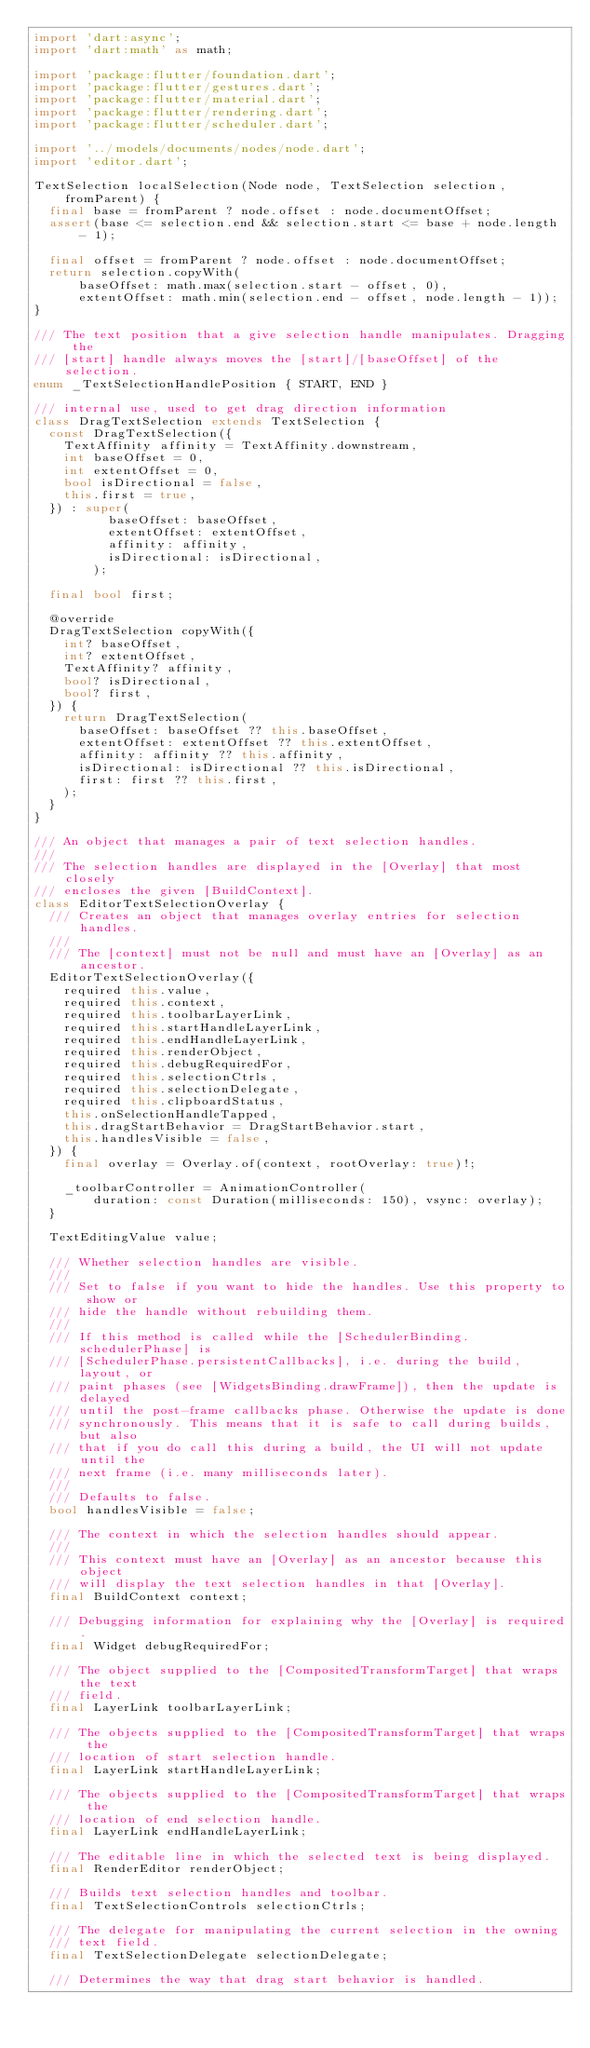<code> <loc_0><loc_0><loc_500><loc_500><_Dart_>import 'dart:async';
import 'dart:math' as math;

import 'package:flutter/foundation.dart';
import 'package:flutter/gestures.dart';
import 'package:flutter/material.dart';
import 'package:flutter/rendering.dart';
import 'package:flutter/scheduler.dart';

import '../models/documents/nodes/node.dart';
import 'editor.dart';

TextSelection localSelection(Node node, TextSelection selection, fromParent) {
  final base = fromParent ? node.offset : node.documentOffset;
  assert(base <= selection.end && selection.start <= base + node.length - 1);

  final offset = fromParent ? node.offset : node.documentOffset;
  return selection.copyWith(
      baseOffset: math.max(selection.start - offset, 0),
      extentOffset: math.min(selection.end - offset, node.length - 1));
}

/// The text position that a give selection handle manipulates. Dragging the
/// [start] handle always moves the [start]/[baseOffset] of the selection.
enum _TextSelectionHandlePosition { START, END }

/// internal use, used to get drag direction information
class DragTextSelection extends TextSelection {
  const DragTextSelection({
    TextAffinity affinity = TextAffinity.downstream,
    int baseOffset = 0,
    int extentOffset = 0,
    bool isDirectional = false,
    this.first = true,
  }) : super(
          baseOffset: baseOffset,
          extentOffset: extentOffset,
          affinity: affinity,
          isDirectional: isDirectional,
        );

  final bool first;

  @override
  DragTextSelection copyWith({
    int? baseOffset,
    int? extentOffset,
    TextAffinity? affinity,
    bool? isDirectional,
    bool? first,
  }) {
    return DragTextSelection(
      baseOffset: baseOffset ?? this.baseOffset,
      extentOffset: extentOffset ?? this.extentOffset,
      affinity: affinity ?? this.affinity,
      isDirectional: isDirectional ?? this.isDirectional,
      first: first ?? this.first,
    );
  }
}

/// An object that manages a pair of text selection handles.
///
/// The selection handles are displayed in the [Overlay] that most closely
/// encloses the given [BuildContext].
class EditorTextSelectionOverlay {
  /// Creates an object that manages overlay entries for selection handles.
  ///
  /// The [context] must not be null and must have an [Overlay] as an ancestor.
  EditorTextSelectionOverlay({
    required this.value,
    required this.context,
    required this.toolbarLayerLink,
    required this.startHandleLayerLink,
    required this.endHandleLayerLink,
    required this.renderObject,
    required this.debugRequiredFor,
    required this.selectionCtrls,
    required this.selectionDelegate,
    required this.clipboardStatus,
    this.onSelectionHandleTapped,
    this.dragStartBehavior = DragStartBehavior.start,
    this.handlesVisible = false,
  }) {
    final overlay = Overlay.of(context, rootOverlay: true)!;

    _toolbarController = AnimationController(
        duration: const Duration(milliseconds: 150), vsync: overlay);
  }

  TextEditingValue value;

  /// Whether selection handles are visible.
  ///
  /// Set to false if you want to hide the handles. Use this property to show or
  /// hide the handle without rebuilding them.
  ///
  /// If this method is called while the [SchedulerBinding.schedulerPhase] is
  /// [SchedulerPhase.persistentCallbacks], i.e. during the build, layout, or
  /// paint phases (see [WidgetsBinding.drawFrame]), then the update is delayed
  /// until the post-frame callbacks phase. Otherwise the update is done
  /// synchronously. This means that it is safe to call during builds, but also
  /// that if you do call this during a build, the UI will not update until the
  /// next frame (i.e. many milliseconds later).
  ///
  /// Defaults to false.
  bool handlesVisible = false;

  /// The context in which the selection handles should appear.
  ///
  /// This context must have an [Overlay] as an ancestor because this object
  /// will display the text selection handles in that [Overlay].
  final BuildContext context;

  /// Debugging information for explaining why the [Overlay] is required.
  final Widget debugRequiredFor;

  /// The object supplied to the [CompositedTransformTarget] that wraps the text
  /// field.
  final LayerLink toolbarLayerLink;

  /// The objects supplied to the [CompositedTransformTarget] that wraps the
  /// location of start selection handle.
  final LayerLink startHandleLayerLink;

  /// The objects supplied to the [CompositedTransformTarget] that wraps the
  /// location of end selection handle.
  final LayerLink endHandleLayerLink;

  /// The editable line in which the selected text is being displayed.
  final RenderEditor renderObject;

  /// Builds text selection handles and toolbar.
  final TextSelectionControls selectionCtrls;

  /// The delegate for manipulating the current selection in the owning
  /// text field.
  final TextSelectionDelegate selectionDelegate;

  /// Determines the way that drag start behavior is handled.</code> 